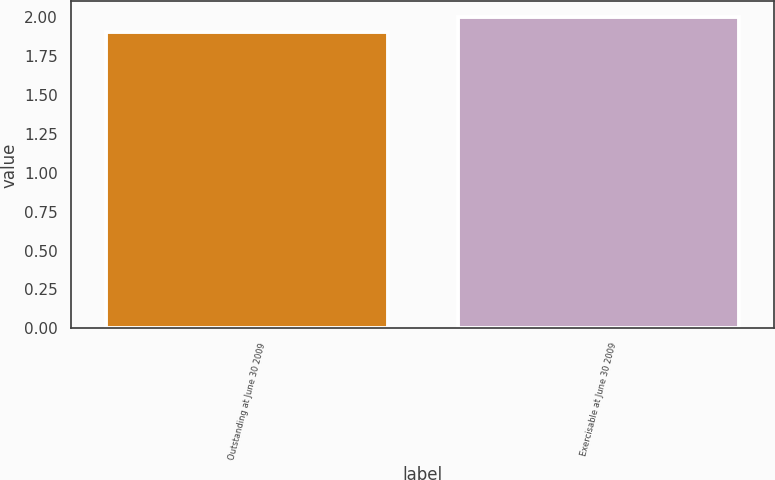Convert chart to OTSL. <chart><loc_0><loc_0><loc_500><loc_500><bar_chart><fcel>Outstanding at June 30 2009<fcel>Exercisable at June 30 2009<nl><fcel>1.9<fcel>2<nl></chart> 